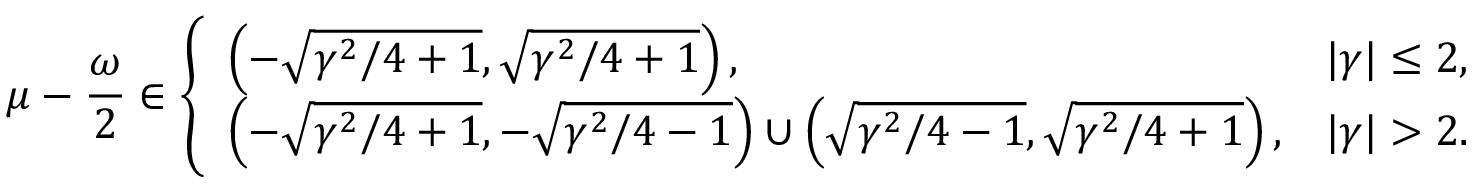Convert formula to latex. <formula><loc_0><loc_0><loc_500><loc_500>\mu - \frac { \omega } { 2 } \in \left \{ \begin{array} { l l } { \left ( - \sqrt { \gamma ^ { 2 } / 4 + 1 } , \sqrt { \gamma ^ { 2 } / 4 + 1 } \right ) , } & { | \gamma | \leq 2 , } \\ { \left ( - \sqrt { \gamma ^ { 2 } / 4 + 1 } , - \sqrt { \gamma ^ { 2 } / 4 - 1 } \right ) \cup \left ( \sqrt { \gamma ^ { 2 } / 4 - 1 } , \sqrt { \gamma ^ { 2 } / 4 + 1 } \right ) , } & { | \gamma | > 2 . } \end{array}</formula> 